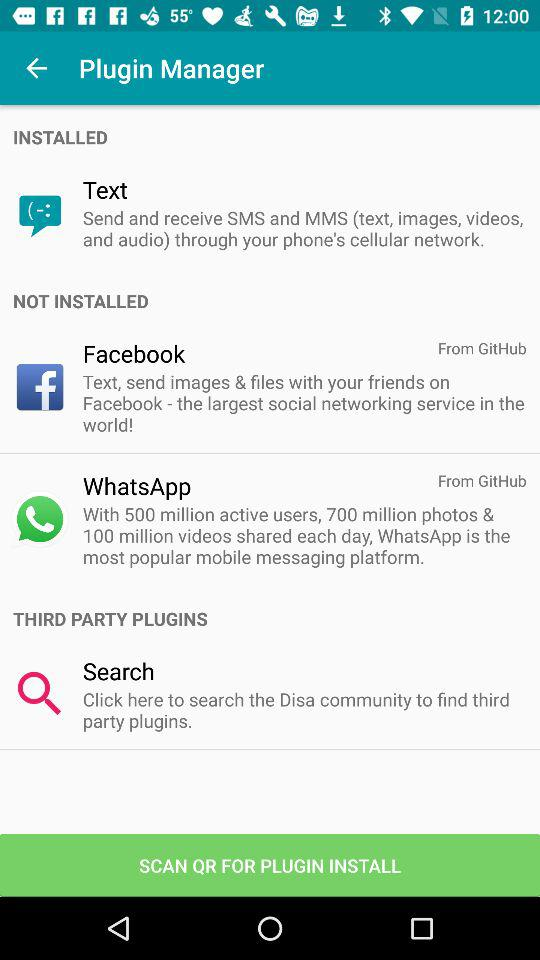How many active users are there of "WhatsApp"? There are 500 million active users of "WhatsApp". 